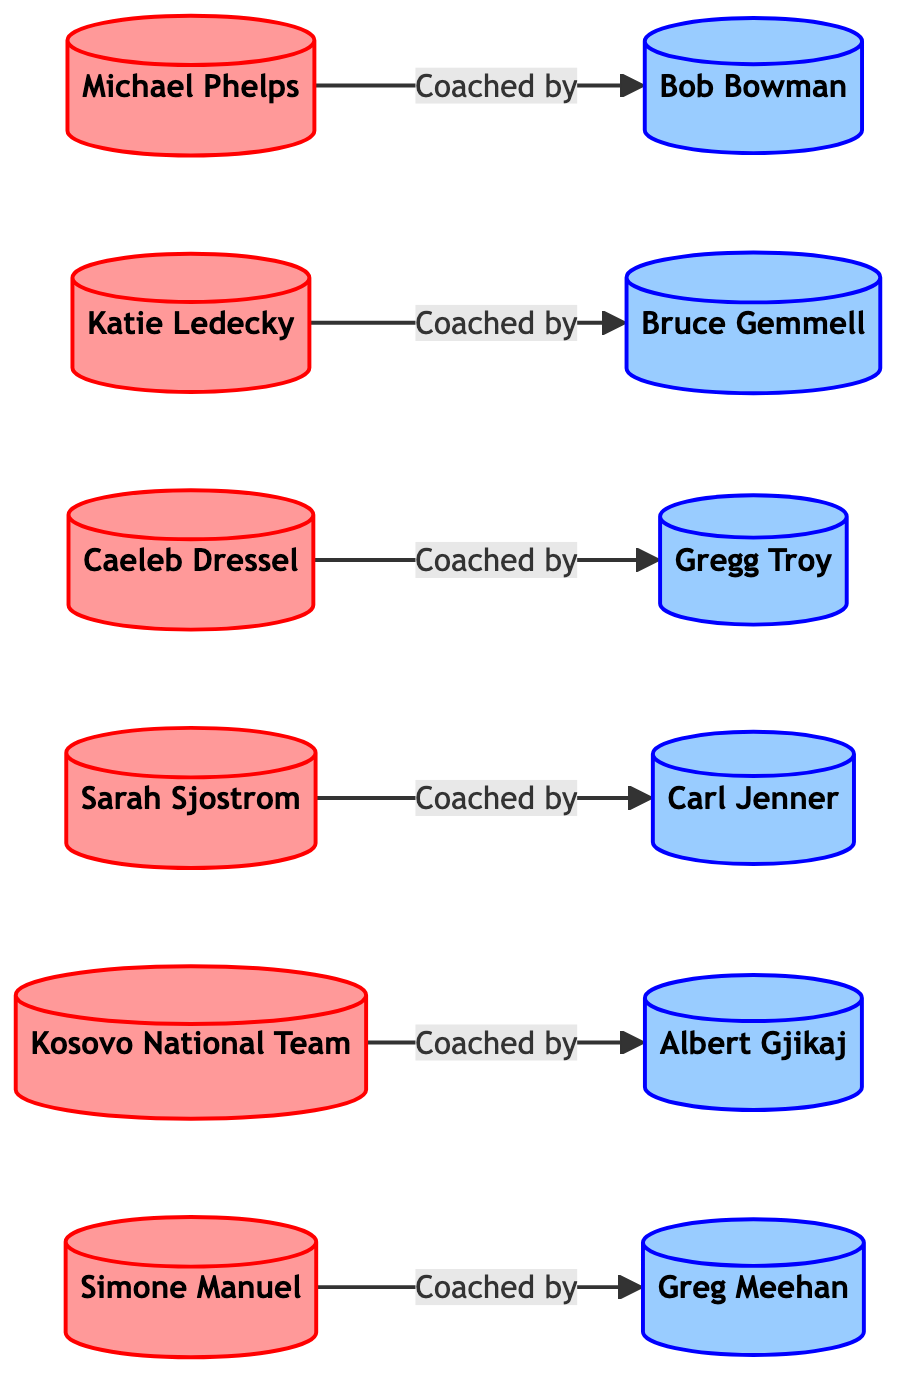What is the total number of swimmers represented in the diagram? The nodes labeled as swimmers are Michael Phelps, Katie Ledecky, Caeleb Dressel, Sarah Sjostrom, Kosovo National Team, and Simone Manuel. Counting these gives a total of 6 swimmers.
Answer: 6 Who is the coach of Katie Ledecky? The diagram shows an edge from Katie Ledecky to Bruce Gemmell labeled "Coached by", indicating that Bruce Gemmell is her coach.
Answer: Bruce Gemmell How many coaches are there in the diagram? By examining the nodes, the coaches are Bob Bowman, Bruce Gemmell, Gregg Troy, Carl Jenner, Albert Gjikaj, and Greg Meehan. This totals to 6 coaches.
Answer: 6 Which swimmer is coached by Bob Bowman? The diagram shows an edge from Michael Phelps to Bob Bowman labeled "Coached by", indicating that Michael Phelps is coached by him.
Answer: Michael Phelps Are there any swimmers coached by more than one coach? The diagram does not show any edges indicating multiple coaching relationships for any swimmer. Each swimmer has a single edge connecting them to one coach, confirming that none are coached by more than one coach in this graph.
Answer: No Which coach oversees the Kosovo National Team? The edge connecting the Kosovo National Team to Albert Gjikaj indicates that he is the coach for the team, according to the diagram.
Answer: Albert Gjikaj What is the relationship between Caeleb Dressel and Gregg Troy? The diagram includes an edge from Caeleb Dressel to Gregg Troy with the label "Coached by", which clearly describes the relationship.
Answer: Coached by How many edges are present in this diagram? By counting each connection where swimmers are related to their respective coaches, there are a total of 6 edges.
Answer: 6 